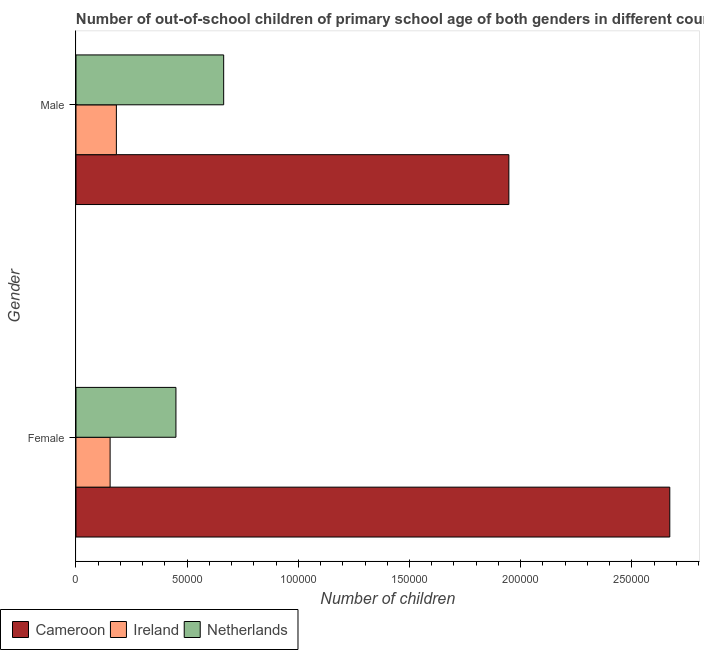How many different coloured bars are there?
Offer a very short reply. 3. How many groups of bars are there?
Provide a succinct answer. 2. How many bars are there on the 2nd tick from the bottom?
Offer a very short reply. 3. What is the number of female out-of-school students in Ireland?
Offer a very short reply. 1.53e+04. Across all countries, what is the maximum number of male out-of-school students?
Offer a terse response. 1.95e+05. Across all countries, what is the minimum number of female out-of-school students?
Your answer should be compact. 1.53e+04. In which country was the number of male out-of-school students maximum?
Your response must be concise. Cameroon. In which country was the number of male out-of-school students minimum?
Make the answer very short. Ireland. What is the total number of female out-of-school students in the graph?
Make the answer very short. 3.27e+05. What is the difference between the number of female out-of-school students in Netherlands and that in Cameroon?
Ensure brevity in your answer.  -2.22e+05. What is the difference between the number of female out-of-school students in Netherlands and the number of male out-of-school students in Ireland?
Your response must be concise. 2.68e+04. What is the average number of female out-of-school students per country?
Your answer should be compact. 1.09e+05. What is the difference between the number of female out-of-school students and number of male out-of-school students in Netherlands?
Offer a terse response. -2.15e+04. What is the ratio of the number of female out-of-school students in Ireland to that in Cameroon?
Offer a terse response. 0.06. Is the number of female out-of-school students in Cameroon less than that in Ireland?
Your response must be concise. No. What does the 3rd bar from the top in Male represents?
Keep it short and to the point. Cameroon. What does the 3rd bar from the bottom in Male represents?
Keep it short and to the point. Netherlands. How many bars are there?
Offer a very short reply. 6. Are all the bars in the graph horizontal?
Give a very brief answer. Yes. How many countries are there in the graph?
Give a very brief answer. 3. Are the values on the major ticks of X-axis written in scientific E-notation?
Your response must be concise. No. Does the graph contain any zero values?
Your answer should be very brief. No. Where does the legend appear in the graph?
Provide a succinct answer. Bottom left. How many legend labels are there?
Provide a succinct answer. 3. What is the title of the graph?
Make the answer very short. Number of out-of-school children of primary school age of both genders in different countries. Does "Bulgaria" appear as one of the legend labels in the graph?
Your answer should be compact. No. What is the label or title of the X-axis?
Offer a terse response. Number of children. What is the label or title of the Y-axis?
Make the answer very short. Gender. What is the Number of children of Cameroon in Female?
Ensure brevity in your answer.  2.67e+05. What is the Number of children in Ireland in Female?
Provide a succinct answer. 1.53e+04. What is the Number of children of Netherlands in Female?
Give a very brief answer. 4.50e+04. What is the Number of children of Cameroon in Male?
Your response must be concise. 1.95e+05. What is the Number of children in Ireland in Male?
Offer a very short reply. 1.82e+04. What is the Number of children of Netherlands in Male?
Your answer should be compact. 6.64e+04. Across all Gender, what is the maximum Number of children in Cameroon?
Provide a short and direct response. 2.67e+05. Across all Gender, what is the maximum Number of children in Ireland?
Your answer should be very brief. 1.82e+04. Across all Gender, what is the maximum Number of children in Netherlands?
Your answer should be very brief. 6.64e+04. Across all Gender, what is the minimum Number of children of Cameroon?
Give a very brief answer. 1.95e+05. Across all Gender, what is the minimum Number of children in Ireland?
Give a very brief answer. 1.53e+04. Across all Gender, what is the minimum Number of children of Netherlands?
Your answer should be compact. 4.50e+04. What is the total Number of children of Cameroon in the graph?
Provide a short and direct response. 4.62e+05. What is the total Number of children of Ireland in the graph?
Offer a very short reply. 3.35e+04. What is the total Number of children of Netherlands in the graph?
Keep it short and to the point. 1.11e+05. What is the difference between the Number of children of Cameroon in Female and that in Male?
Offer a terse response. 7.24e+04. What is the difference between the Number of children of Ireland in Female and that in Male?
Provide a short and direct response. -2814. What is the difference between the Number of children of Netherlands in Female and that in Male?
Provide a short and direct response. -2.15e+04. What is the difference between the Number of children of Cameroon in Female and the Number of children of Ireland in Male?
Keep it short and to the point. 2.49e+05. What is the difference between the Number of children of Cameroon in Female and the Number of children of Netherlands in Male?
Your response must be concise. 2.01e+05. What is the difference between the Number of children of Ireland in Female and the Number of children of Netherlands in Male?
Offer a terse response. -5.11e+04. What is the average Number of children in Cameroon per Gender?
Ensure brevity in your answer.  2.31e+05. What is the average Number of children in Ireland per Gender?
Ensure brevity in your answer.  1.68e+04. What is the average Number of children of Netherlands per Gender?
Keep it short and to the point. 5.57e+04. What is the difference between the Number of children of Cameroon and Number of children of Ireland in Female?
Make the answer very short. 2.52e+05. What is the difference between the Number of children in Cameroon and Number of children in Netherlands in Female?
Make the answer very short. 2.22e+05. What is the difference between the Number of children in Ireland and Number of children in Netherlands in Female?
Keep it short and to the point. -2.96e+04. What is the difference between the Number of children in Cameroon and Number of children in Ireland in Male?
Offer a terse response. 1.77e+05. What is the difference between the Number of children of Cameroon and Number of children of Netherlands in Male?
Make the answer very short. 1.28e+05. What is the difference between the Number of children of Ireland and Number of children of Netherlands in Male?
Provide a short and direct response. -4.83e+04. What is the ratio of the Number of children in Cameroon in Female to that in Male?
Provide a succinct answer. 1.37. What is the ratio of the Number of children of Ireland in Female to that in Male?
Give a very brief answer. 0.85. What is the ratio of the Number of children of Netherlands in Female to that in Male?
Your response must be concise. 0.68. What is the difference between the highest and the second highest Number of children of Cameroon?
Make the answer very short. 7.24e+04. What is the difference between the highest and the second highest Number of children in Ireland?
Offer a terse response. 2814. What is the difference between the highest and the second highest Number of children of Netherlands?
Provide a short and direct response. 2.15e+04. What is the difference between the highest and the lowest Number of children in Cameroon?
Your response must be concise. 7.24e+04. What is the difference between the highest and the lowest Number of children of Ireland?
Your answer should be compact. 2814. What is the difference between the highest and the lowest Number of children in Netherlands?
Make the answer very short. 2.15e+04. 